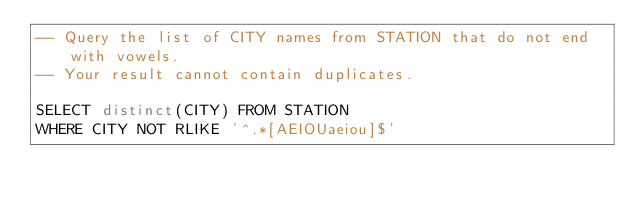Convert code to text. <code><loc_0><loc_0><loc_500><loc_500><_SQL_>-- Query the list of CITY names from STATION that do not end with vowels. 
-- Your result cannot contain duplicates.

SELECT distinct(CITY) FROM STATION 
WHERE CITY NOT RLIKE '^.*[AEIOUaeiou]$'</code> 